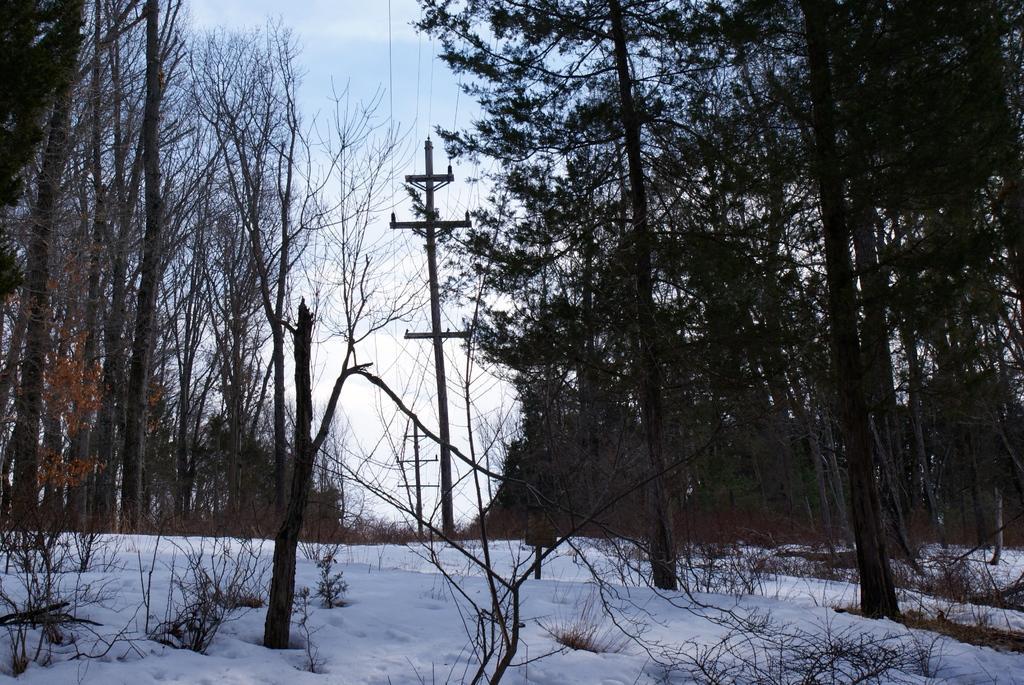In one or two sentences, can you explain what this image depicts? This is an outside view. At the bottom, I can see the snow and some plants. In the middle of the image there are few poles along with the wires. On the right and left side of the image there are many trees. At the of the image I can see the sky. 